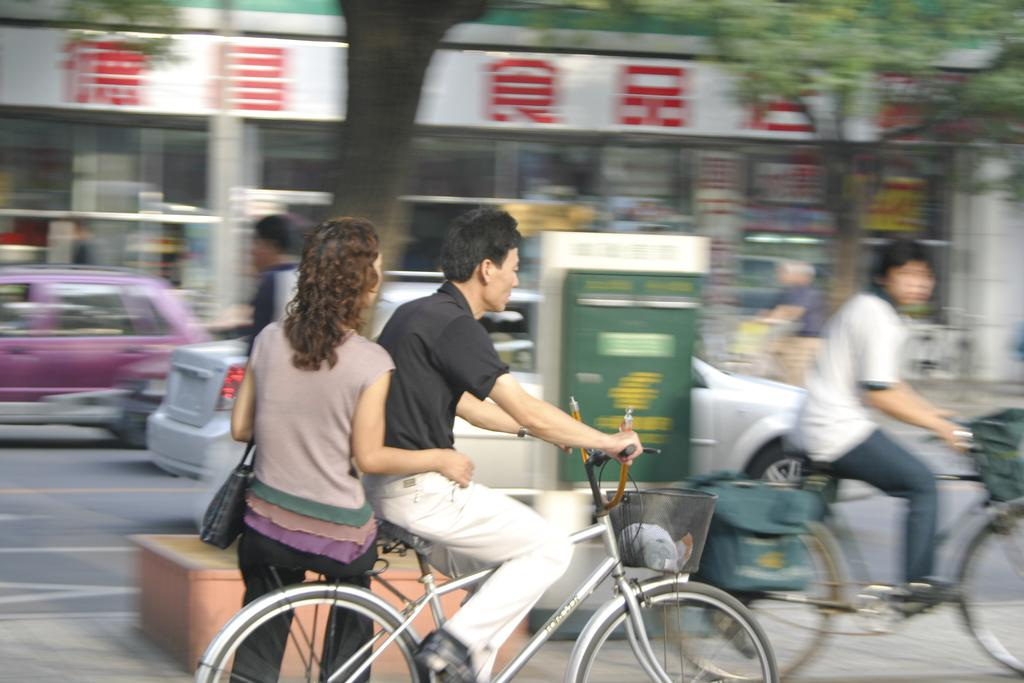What are the people in the image doing? The people in the image are sitting on bicycles. How are the bicycles being used? The people are riding the bicycles on the road. What can be seen in the background of the image? There are cars, trees, and at least one building visible in the background. Can you see any goldfish swimming in the image? There are no goldfish present in the image. What type of boat can be seen in the image? There is no boat present in the image. 